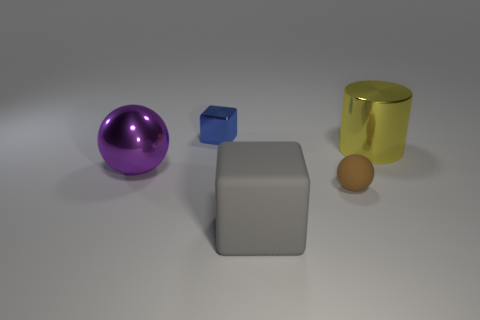What materials do the objects in the image appear to be made of? The sphere appears to be made of a shiny plastic, the small cube looks like a matte material, possibly clay, the larger gray cube seems to be rubber, and the cylindrical object has a metallic finish. 